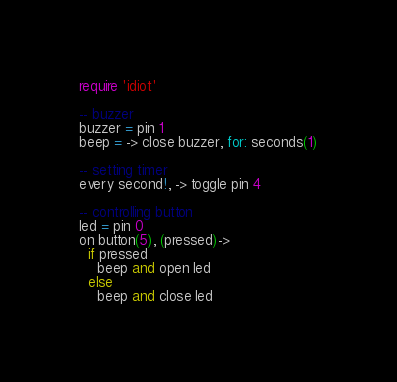Convert code to text. <code><loc_0><loc_0><loc_500><loc_500><_MoonScript_>require 'idiot'

-- buzzer
buzzer = pin 1
beep = -> close buzzer, for: seconds(1)

-- setting timer
every second!, -> toggle pin 4

-- controlling button
led = pin 0
on button(5), (pressed)->
  if pressed
    beep and open led
  else
    beep and close led
</code> 